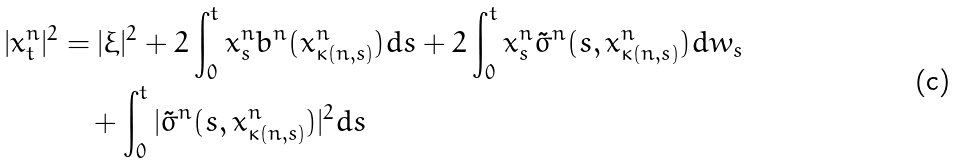Convert formula to latex. <formula><loc_0><loc_0><loc_500><loc_500>| x _ { t } ^ { n } | ^ { 2 } & = | \xi | ^ { 2 } + 2 \int _ { 0 } ^ { t } x _ { s } ^ { n } b ^ { n } ( x _ { \kappa ( n , s ) } ^ { n } ) d s + 2 \int _ { 0 } ^ { t } x _ { s } ^ { n } \tilde { \sigma } ^ { n } ( s , x _ { \kappa ( n , s ) } ^ { n } ) d w _ { s } \\ & \quad + \int _ { 0 } ^ { t } | \tilde { \sigma } ^ { n } ( s , x _ { \kappa ( n , s ) } ^ { n } ) | ^ { 2 } d s</formula> 